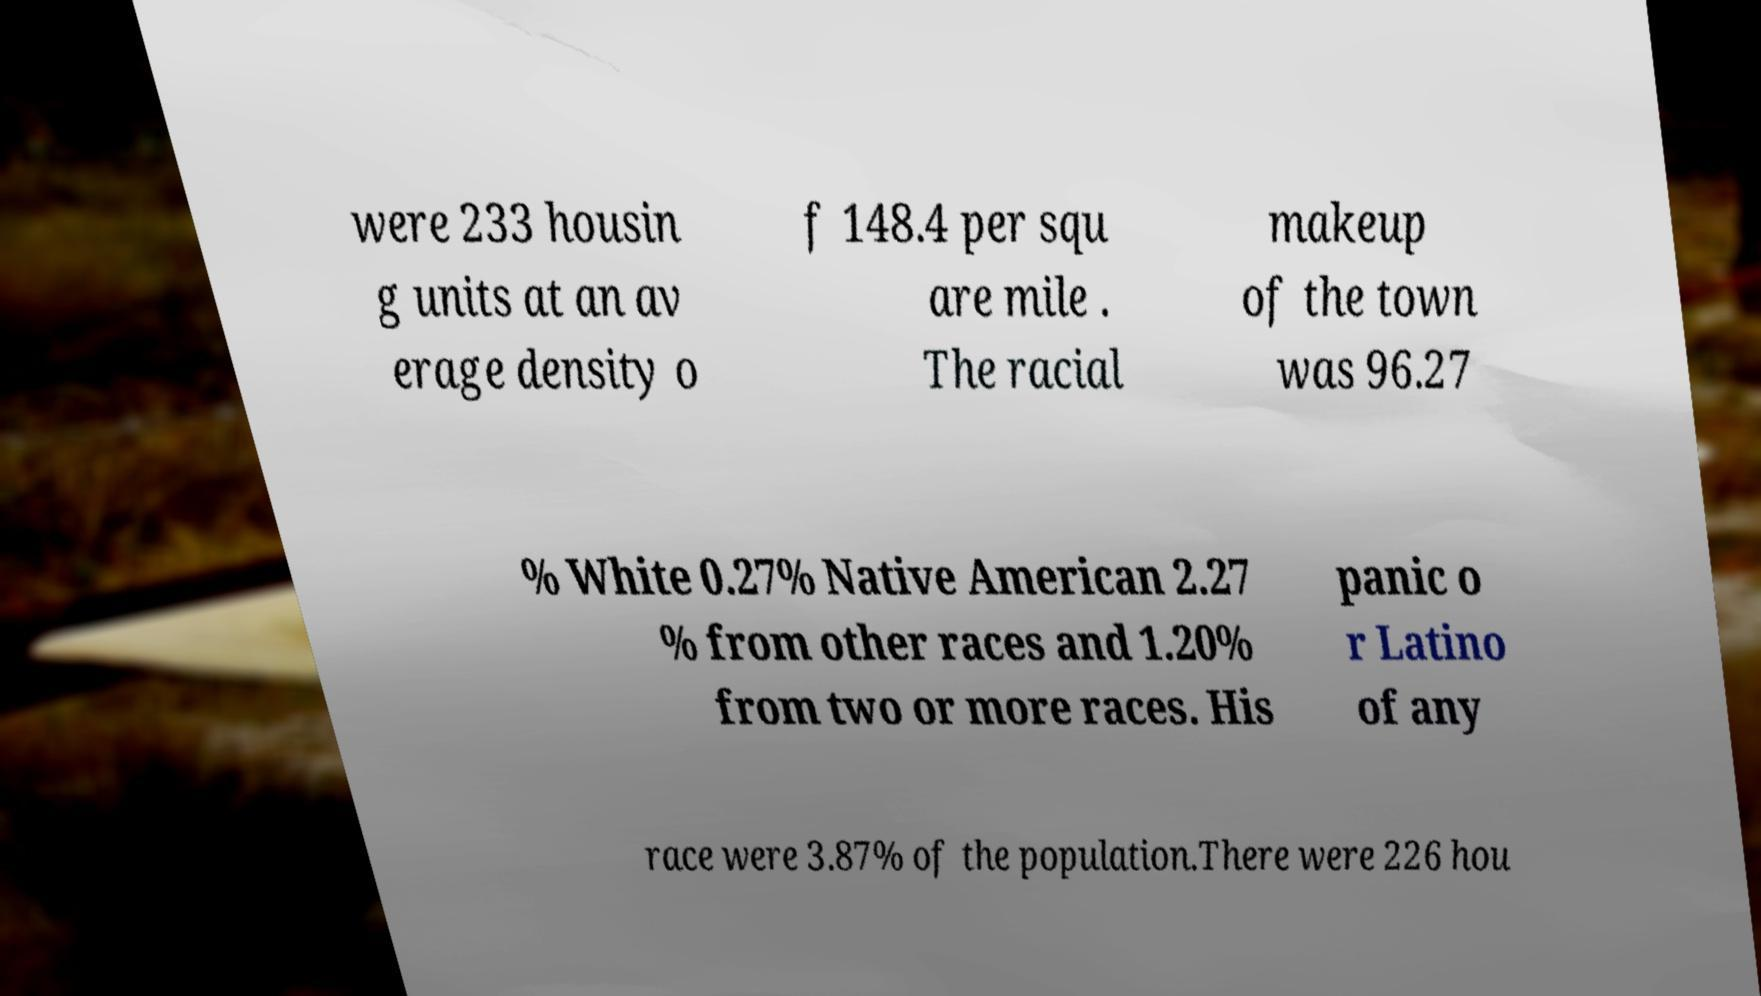Could you extract and type out the text from this image? were 233 housin g units at an av erage density o f 148.4 per squ are mile . The racial makeup of the town was 96.27 % White 0.27% Native American 2.27 % from other races and 1.20% from two or more races. His panic o r Latino of any race were 3.87% of the population.There were 226 hou 